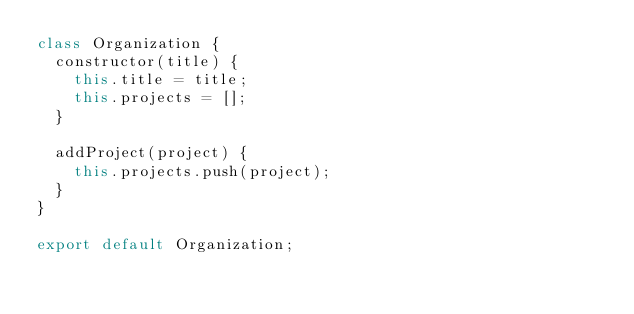<code> <loc_0><loc_0><loc_500><loc_500><_JavaScript_>class Organization {
  constructor(title) {
    this.title = title;
    this.projects = [];
  }

  addProject(project) {
    this.projects.push(project);
  }
}

export default Organization;</code> 